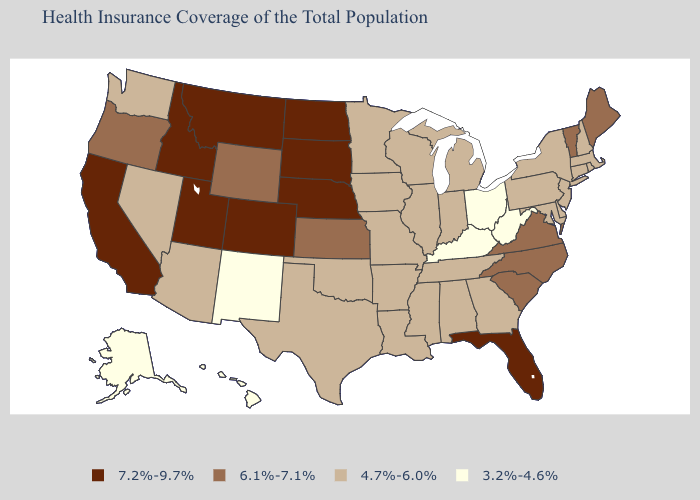Does Nebraska have the highest value in the USA?
Short answer required. Yes. Name the states that have a value in the range 6.1%-7.1%?
Answer briefly. Kansas, Maine, North Carolina, Oregon, South Carolina, Vermont, Virginia, Wyoming. Among the states that border Pennsylvania , which have the highest value?
Concise answer only. Delaware, Maryland, New Jersey, New York. What is the lowest value in the USA?
Write a very short answer. 3.2%-4.6%. Name the states that have a value in the range 6.1%-7.1%?
Be succinct. Kansas, Maine, North Carolina, Oregon, South Carolina, Vermont, Virginia, Wyoming. Does Colorado have the lowest value in the USA?
Quick response, please. No. What is the value of Hawaii?
Answer briefly. 3.2%-4.6%. Which states hav the highest value in the West?
Concise answer only. California, Colorado, Idaho, Montana, Utah. Name the states that have a value in the range 6.1%-7.1%?
Be succinct. Kansas, Maine, North Carolina, Oregon, South Carolina, Vermont, Virginia, Wyoming. What is the lowest value in the West?
Keep it brief. 3.2%-4.6%. How many symbols are there in the legend?
Keep it brief. 4. Which states hav the highest value in the Northeast?
Keep it brief. Maine, Vermont. Does New York have the lowest value in the Northeast?
Keep it brief. Yes. What is the value of New Mexico?
Concise answer only. 3.2%-4.6%. What is the lowest value in states that border Montana?
Write a very short answer. 6.1%-7.1%. 